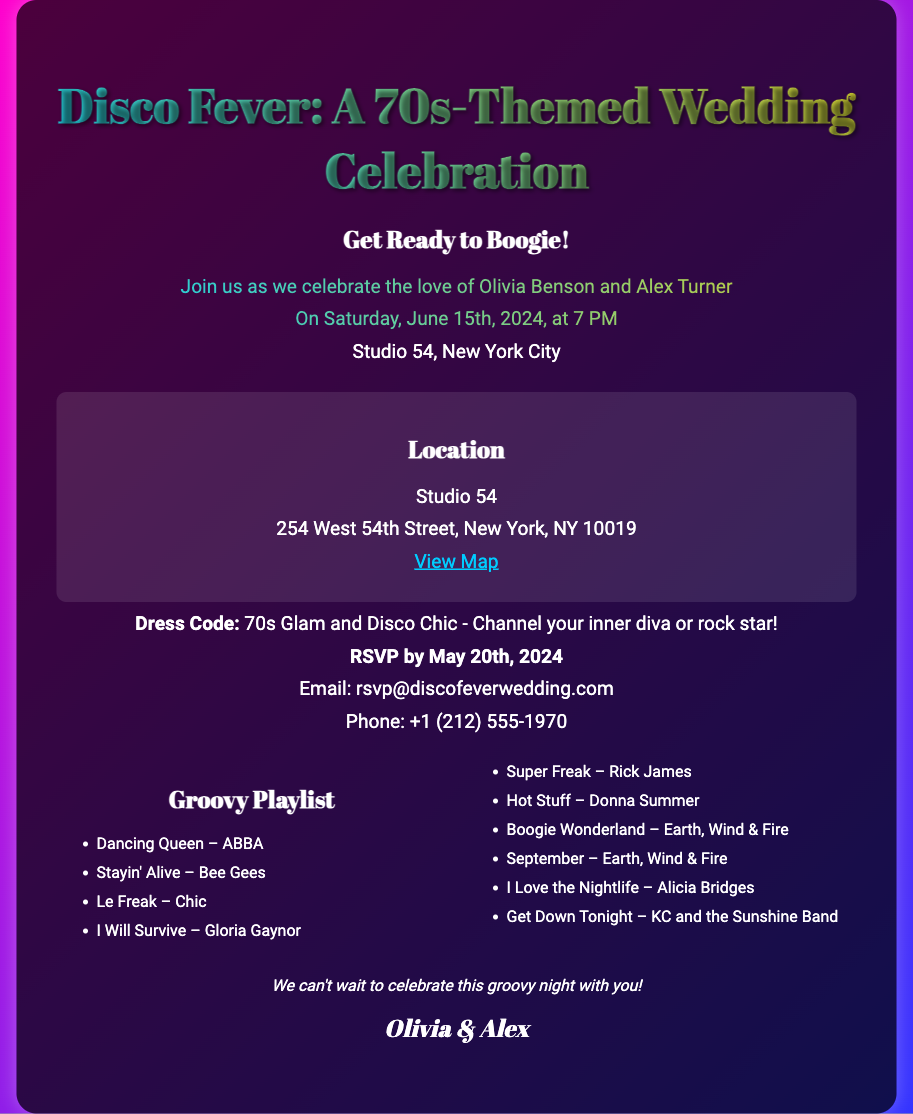What is the name of the couple getting married? The couple getting married is mentioned in the invitation under the introductory text.
Answer: Olivia Benson and Alex Turner What date is the wedding scheduled for? The date of the wedding is provided in the introductory section of the invitation.
Answer: June 15th, 2024 What is the address of the wedding venue? The address is specified under the location section within the details of the invitation.
Answer: 254 West 54th Street, New York, NY 10019 What is the RSVP deadline? The RSVP deadline is highlighted in the details section of the invitation.
Answer: May 20th, 2024 What is suggested as the dress code for the wedding? The dress code is mentioned under the details section, indicating the style guests should wear.
Answer: 70s Glam and Disco Chic How many songs are listed in the Groovy Playlist? The number of songs is counted from the playlist section of the invitation.
Answer: 10 Which song by ABBA is included in the playlist? The song by ABBA listed in the playlist can be found in the Groovy Playlist section.
Answer: Dancing Queen What type of event is this invitation for? The overall purpose of the document is to announce a specific type of celebration.
Answer: Wedding What city is the wedding taking place in? The city where the wedding will occur is mentioned in the introductory section of the invitation.
Answer: New York City 